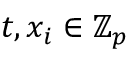Convert formula to latex. <formula><loc_0><loc_0><loc_500><loc_500>t , x _ { i } \in \mathbb { Z } _ { p }</formula> 